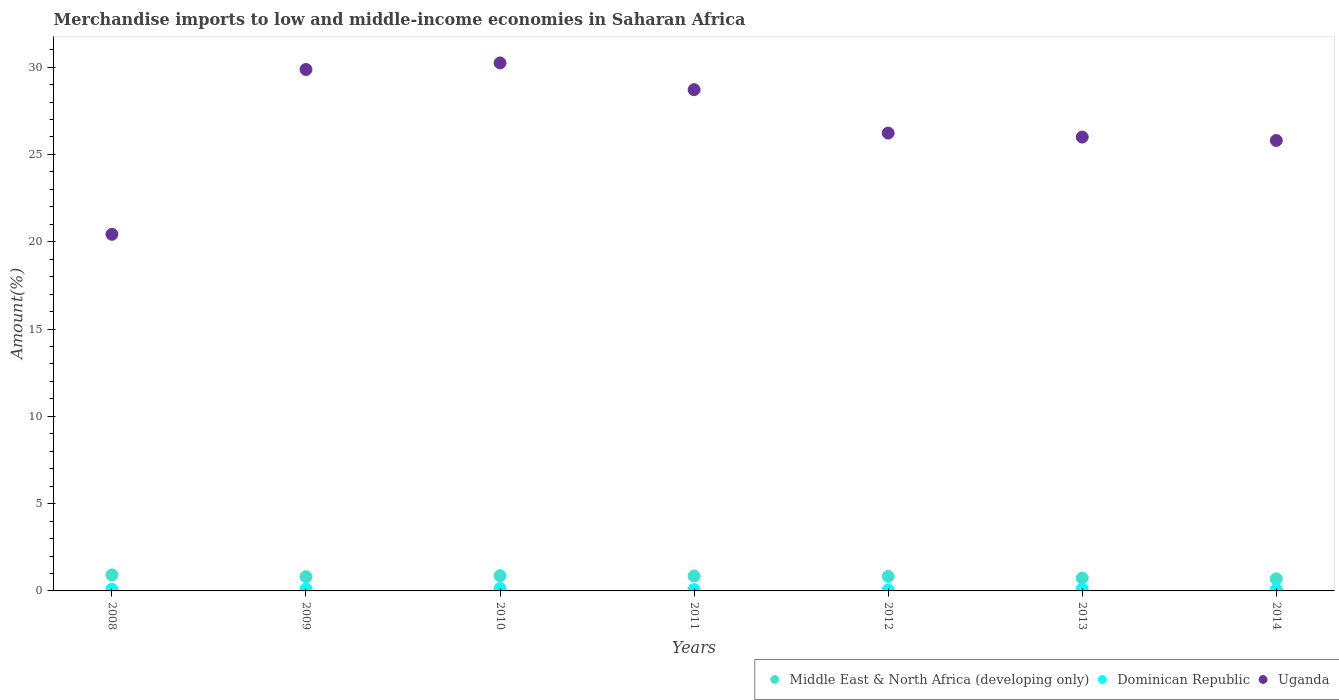How many different coloured dotlines are there?
Give a very brief answer. 3. Is the number of dotlines equal to the number of legend labels?
Provide a succinct answer. Yes. What is the percentage of amount earned from merchandise imports in Middle East & North Africa (developing only) in 2008?
Your answer should be very brief. 0.92. Across all years, what is the maximum percentage of amount earned from merchandise imports in Dominican Republic?
Offer a terse response. 0.14. Across all years, what is the minimum percentage of amount earned from merchandise imports in Middle East & North Africa (developing only)?
Provide a succinct answer. 0.69. In which year was the percentage of amount earned from merchandise imports in Uganda minimum?
Offer a terse response. 2008. What is the total percentage of amount earned from merchandise imports in Dominican Republic in the graph?
Your response must be concise. 0.66. What is the difference between the percentage of amount earned from merchandise imports in Dominican Republic in 2009 and that in 2012?
Your answer should be very brief. 0.05. What is the difference between the percentage of amount earned from merchandise imports in Middle East & North Africa (developing only) in 2009 and the percentage of amount earned from merchandise imports in Uganda in 2010?
Your answer should be compact. -29.43. What is the average percentage of amount earned from merchandise imports in Dominican Republic per year?
Provide a short and direct response. 0.09. In the year 2014, what is the difference between the percentage of amount earned from merchandise imports in Uganda and percentage of amount earned from merchandise imports in Middle East & North Africa (developing only)?
Provide a short and direct response. 25.11. In how many years, is the percentage of amount earned from merchandise imports in Uganda greater than 10 %?
Your response must be concise. 7. What is the ratio of the percentage of amount earned from merchandise imports in Uganda in 2009 to that in 2013?
Offer a very short reply. 1.15. Is the difference between the percentage of amount earned from merchandise imports in Uganda in 2011 and 2012 greater than the difference between the percentage of amount earned from merchandise imports in Middle East & North Africa (developing only) in 2011 and 2012?
Your answer should be compact. Yes. What is the difference between the highest and the second highest percentage of amount earned from merchandise imports in Dominican Republic?
Offer a very short reply. 0.02. What is the difference between the highest and the lowest percentage of amount earned from merchandise imports in Uganda?
Provide a succinct answer. 9.82. Is it the case that in every year, the sum of the percentage of amount earned from merchandise imports in Middle East & North Africa (developing only) and percentage of amount earned from merchandise imports in Dominican Republic  is greater than the percentage of amount earned from merchandise imports in Uganda?
Provide a short and direct response. No. Does the percentage of amount earned from merchandise imports in Uganda monotonically increase over the years?
Your response must be concise. No. Is the percentage of amount earned from merchandise imports in Middle East & North Africa (developing only) strictly less than the percentage of amount earned from merchandise imports in Uganda over the years?
Keep it short and to the point. Yes. How many dotlines are there?
Your answer should be compact. 3. How many years are there in the graph?
Your answer should be compact. 7. What is the difference between two consecutive major ticks on the Y-axis?
Keep it short and to the point. 5. Does the graph contain any zero values?
Your answer should be very brief. No. Does the graph contain grids?
Offer a very short reply. No. How many legend labels are there?
Your answer should be very brief. 3. What is the title of the graph?
Provide a short and direct response. Merchandise imports to low and middle-income economies in Saharan Africa. What is the label or title of the X-axis?
Provide a short and direct response. Years. What is the label or title of the Y-axis?
Give a very brief answer. Amount(%). What is the Amount(%) in Middle East & North Africa (developing only) in 2008?
Your response must be concise. 0.92. What is the Amount(%) of Dominican Republic in 2008?
Provide a succinct answer. 0.09. What is the Amount(%) in Uganda in 2008?
Ensure brevity in your answer.  20.43. What is the Amount(%) of Middle East & North Africa (developing only) in 2009?
Ensure brevity in your answer.  0.81. What is the Amount(%) in Dominican Republic in 2009?
Your answer should be very brief. 0.11. What is the Amount(%) of Uganda in 2009?
Provide a short and direct response. 29.87. What is the Amount(%) of Middle East & North Africa (developing only) in 2010?
Provide a succinct answer. 0.87. What is the Amount(%) in Dominican Republic in 2010?
Make the answer very short. 0.14. What is the Amount(%) in Uganda in 2010?
Give a very brief answer. 30.24. What is the Amount(%) in Middle East & North Africa (developing only) in 2011?
Your response must be concise. 0.85. What is the Amount(%) in Dominican Republic in 2011?
Your answer should be very brief. 0.08. What is the Amount(%) of Uganda in 2011?
Offer a very short reply. 28.71. What is the Amount(%) in Middle East & North Africa (developing only) in 2012?
Provide a short and direct response. 0.83. What is the Amount(%) in Dominican Republic in 2012?
Make the answer very short. 0.06. What is the Amount(%) of Uganda in 2012?
Give a very brief answer. 26.22. What is the Amount(%) in Middle East & North Africa (developing only) in 2013?
Your answer should be very brief. 0.74. What is the Amount(%) of Dominican Republic in 2013?
Offer a terse response. 0.1. What is the Amount(%) of Uganda in 2013?
Provide a succinct answer. 25.99. What is the Amount(%) in Middle East & North Africa (developing only) in 2014?
Provide a succinct answer. 0.69. What is the Amount(%) in Dominican Republic in 2014?
Keep it short and to the point. 0.09. What is the Amount(%) of Uganda in 2014?
Keep it short and to the point. 25.8. Across all years, what is the maximum Amount(%) in Middle East & North Africa (developing only)?
Your response must be concise. 0.92. Across all years, what is the maximum Amount(%) of Dominican Republic?
Keep it short and to the point. 0.14. Across all years, what is the maximum Amount(%) of Uganda?
Keep it short and to the point. 30.24. Across all years, what is the minimum Amount(%) of Middle East & North Africa (developing only)?
Provide a succinct answer. 0.69. Across all years, what is the minimum Amount(%) in Dominican Republic?
Offer a very short reply. 0.06. Across all years, what is the minimum Amount(%) in Uganda?
Provide a short and direct response. 20.43. What is the total Amount(%) of Middle East & North Africa (developing only) in the graph?
Give a very brief answer. 5.72. What is the total Amount(%) in Dominican Republic in the graph?
Ensure brevity in your answer.  0.66. What is the total Amount(%) of Uganda in the graph?
Offer a very short reply. 187.26. What is the difference between the Amount(%) in Middle East & North Africa (developing only) in 2008 and that in 2009?
Provide a succinct answer. 0.1. What is the difference between the Amount(%) of Dominican Republic in 2008 and that in 2009?
Give a very brief answer. -0.02. What is the difference between the Amount(%) of Uganda in 2008 and that in 2009?
Make the answer very short. -9.44. What is the difference between the Amount(%) in Middle East & North Africa (developing only) in 2008 and that in 2010?
Offer a very short reply. 0.05. What is the difference between the Amount(%) of Dominican Republic in 2008 and that in 2010?
Your response must be concise. -0.05. What is the difference between the Amount(%) of Uganda in 2008 and that in 2010?
Your answer should be compact. -9.82. What is the difference between the Amount(%) of Middle East & North Africa (developing only) in 2008 and that in 2011?
Provide a succinct answer. 0.06. What is the difference between the Amount(%) in Dominican Republic in 2008 and that in 2011?
Give a very brief answer. 0.01. What is the difference between the Amount(%) of Uganda in 2008 and that in 2011?
Your response must be concise. -8.29. What is the difference between the Amount(%) in Middle East & North Africa (developing only) in 2008 and that in 2012?
Offer a terse response. 0.09. What is the difference between the Amount(%) of Dominican Republic in 2008 and that in 2012?
Your answer should be very brief. 0.03. What is the difference between the Amount(%) in Uganda in 2008 and that in 2012?
Keep it short and to the point. -5.8. What is the difference between the Amount(%) in Middle East & North Africa (developing only) in 2008 and that in 2013?
Keep it short and to the point. 0.18. What is the difference between the Amount(%) in Dominican Republic in 2008 and that in 2013?
Provide a succinct answer. -0.02. What is the difference between the Amount(%) of Uganda in 2008 and that in 2013?
Make the answer very short. -5.57. What is the difference between the Amount(%) in Middle East & North Africa (developing only) in 2008 and that in 2014?
Your answer should be very brief. 0.22. What is the difference between the Amount(%) in Dominican Republic in 2008 and that in 2014?
Ensure brevity in your answer.  0. What is the difference between the Amount(%) of Uganda in 2008 and that in 2014?
Your answer should be very brief. -5.38. What is the difference between the Amount(%) of Middle East & North Africa (developing only) in 2009 and that in 2010?
Provide a succinct answer. -0.06. What is the difference between the Amount(%) of Dominican Republic in 2009 and that in 2010?
Make the answer very short. -0.02. What is the difference between the Amount(%) of Uganda in 2009 and that in 2010?
Provide a succinct answer. -0.38. What is the difference between the Amount(%) of Middle East & North Africa (developing only) in 2009 and that in 2011?
Ensure brevity in your answer.  -0.04. What is the difference between the Amount(%) of Dominican Republic in 2009 and that in 2011?
Give a very brief answer. 0.03. What is the difference between the Amount(%) in Uganda in 2009 and that in 2011?
Your answer should be very brief. 1.16. What is the difference between the Amount(%) of Middle East & North Africa (developing only) in 2009 and that in 2012?
Provide a short and direct response. -0.02. What is the difference between the Amount(%) of Dominican Republic in 2009 and that in 2012?
Your response must be concise. 0.05. What is the difference between the Amount(%) in Uganda in 2009 and that in 2012?
Provide a short and direct response. 3.64. What is the difference between the Amount(%) of Middle East & North Africa (developing only) in 2009 and that in 2013?
Provide a succinct answer. 0.08. What is the difference between the Amount(%) in Dominican Republic in 2009 and that in 2013?
Your answer should be compact. 0.01. What is the difference between the Amount(%) of Uganda in 2009 and that in 2013?
Your answer should be very brief. 3.87. What is the difference between the Amount(%) in Middle East & North Africa (developing only) in 2009 and that in 2014?
Your answer should be compact. 0.12. What is the difference between the Amount(%) in Dominican Republic in 2009 and that in 2014?
Keep it short and to the point. 0.03. What is the difference between the Amount(%) in Uganda in 2009 and that in 2014?
Your answer should be very brief. 4.07. What is the difference between the Amount(%) in Middle East & North Africa (developing only) in 2010 and that in 2011?
Give a very brief answer. 0.02. What is the difference between the Amount(%) of Dominican Republic in 2010 and that in 2011?
Offer a very short reply. 0.06. What is the difference between the Amount(%) in Uganda in 2010 and that in 2011?
Provide a short and direct response. 1.53. What is the difference between the Amount(%) of Middle East & North Africa (developing only) in 2010 and that in 2012?
Offer a very short reply. 0.04. What is the difference between the Amount(%) of Dominican Republic in 2010 and that in 2012?
Provide a succinct answer. 0.07. What is the difference between the Amount(%) of Uganda in 2010 and that in 2012?
Offer a very short reply. 4.02. What is the difference between the Amount(%) in Middle East & North Africa (developing only) in 2010 and that in 2013?
Your answer should be very brief. 0.13. What is the difference between the Amount(%) of Dominican Republic in 2010 and that in 2013?
Make the answer very short. 0.03. What is the difference between the Amount(%) in Uganda in 2010 and that in 2013?
Provide a short and direct response. 4.25. What is the difference between the Amount(%) in Middle East & North Africa (developing only) in 2010 and that in 2014?
Ensure brevity in your answer.  0.18. What is the difference between the Amount(%) in Dominican Republic in 2010 and that in 2014?
Provide a succinct answer. 0.05. What is the difference between the Amount(%) in Uganda in 2010 and that in 2014?
Provide a succinct answer. 4.44. What is the difference between the Amount(%) of Middle East & North Africa (developing only) in 2011 and that in 2012?
Provide a succinct answer. 0.02. What is the difference between the Amount(%) of Dominican Republic in 2011 and that in 2012?
Give a very brief answer. 0.02. What is the difference between the Amount(%) in Uganda in 2011 and that in 2012?
Make the answer very short. 2.49. What is the difference between the Amount(%) in Middle East & North Africa (developing only) in 2011 and that in 2013?
Ensure brevity in your answer.  0.12. What is the difference between the Amount(%) in Dominican Republic in 2011 and that in 2013?
Your answer should be compact. -0.03. What is the difference between the Amount(%) of Uganda in 2011 and that in 2013?
Your answer should be very brief. 2.72. What is the difference between the Amount(%) in Middle East & North Africa (developing only) in 2011 and that in 2014?
Provide a succinct answer. 0.16. What is the difference between the Amount(%) of Dominican Republic in 2011 and that in 2014?
Your answer should be compact. -0.01. What is the difference between the Amount(%) in Uganda in 2011 and that in 2014?
Make the answer very short. 2.91. What is the difference between the Amount(%) in Middle East & North Africa (developing only) in 2012 and that in 2013?
Give a very brief answer. 0.09. What is the difference between the Amount(%) of Dominican Republic in 2012 and that in 2013?
Make the answer very short. -0.04. What is the difference between the Amount(%) of Uganda in 2012 and that in 2013?
Give a very brief answer. 0.23. What is the difference between the Amount(%) in Middle East & North Africa (developing only) in 2012 and that in 2014?
Your answer should be very brief. 0.14. What is the difference between the Amount(%) of Dominican Republic in 2012 and that in 2014?
Give a very brief answer. -0.02. What is the difference between the Amount(%) of Uganda in 2012 and that in 2014?
Offer a terse response. 0.42. What is the difference between the Amount(%) in Middle East & North Africa (developing only) in 2013 and that in 2014?
Your answer should be compact. 0.05. What is the difference between the Amount(%) of Dominican Republic in 2013 and that in 2014?
Offer a very short reply. 0.02. What is the difference between the Amount(%) in Uganda in 2013 and that in 2014?
Offer a terse response. 0.19. What is the difference between the Amount(%) of Middle East & North Africa (developing only) in 2008 and the Amount(%) of Dominican Republic in 2009?
Keep it short and to the point. 0.81. What is the difference between the Amount(%) of Middle East & North Africa (developing only) in 2008 and the Amount(%) of Uganda in 2009?
Provide a short and direct response. -28.95. What is the difference between the Amount(%) of Dominican Republic in 2008 and the Amount(%) of Uganda in 2009?
Your response must be concise. -29.78. What is the difference between the Amount(%) in Middle East & North Africa (developing only) in 2008 and the Amount(%) in Dominican Republic in 2010?
Keep it short and to the point. 0.78. What is the difference between the Amount(%) in Middle East & North Africa (developing only) in 2008 and the Amount(%) in Uganda in 2010?
Provide a succinct answer. -29.33. What is the difference between the Amount(%) of Dominican Republic in 2008 and the Amount(%) of Uganda in 2010?
Keep it short and to the point. -30.15. What is the difference between the Amount(%) in Middle East & North Africa (developing only) in 2008 and the Amount(%) in Dominican Republic in 2011?
Provide a short and direct response. 0.84. What is the difference between the Amount(%) in Middle East & North Africa (developing only) in 2008 and the Amount(%) in Uganda in 2011?
Offer a very short reply. -27.79. What is the difference between the Amount(%) in Dominican Republic in 2008 and the Amount(%) in Uganda in 2011?
Make the answer very short. -28.62. What is the difference between the Amount(%) in Middle East & North Africa (developing only) in 2008 and the Amount(%) in Dominican Republic in 2012?
Provide a succinct answer. 0.86. What is the difference between the Amount(%) of Middle East & North Africa (developing only) in 2008 and the Amount(%) of Uganda in 2012?
Keep it short and to the point. -25.31. What is the difference between the Amount(%) of Dominican Republic in 2008 and the Amount(%) of Uganda in 2012?
Offer a terse response. -26.13. What is the difference between the Amount(%) of Middle East & North Africa (developing only) in 2008 and the Amount(%) of Dominican Republic in 2013?
Provide a succinct answer. 0.81. What is the difference between the Amount(%) of Middle East & North Africa (developing only) in 2008 and the Amount(%) of Uganda in 2013?
Keep it short and to the point. -25.08. What is the difference between the Amount(%) of Dominican Republic in 2008 and the Amount(%) of Uganda in 2013?
Ensure brevity in your answer.  -25.91. What is the difference between the Amount(%) of Middle East & North Africa (developing only) in 2008 and the Amount(%) of Dominican Republic in 2014?
Offer a terse response. 0.83. What is the difference between the Amount(%) of Middle East & North Africa (developing only) in 2008 and the Amount(%) of Uganda in 2014?
Keep it short and to the point. -24.88. What is the difference between the Amount(%) of Dominican Republic in 2008 and the Amount(%) of Uganda in 2014?
Provide a short and direct response. -25.71. What is the difference between the Amount(%) in Middle East & North Africa (developing only) in 2009 and the Amount(%) in Dominican Republic in 2010?
Your answer should be compact. 0.68. What is the difference between the Amount(%) in Middle East & North Africa (developing only) in 2009 and the Amount(%) in Uganda in 2010?
Keep it short and to the point. -29.43. What is the difference between the Amount(%) in Dominican Republic in 2009 and the Amount(%) in Uganda in 2010?
Ensure brevity in your answer.  -30.13. What is the difference between the Amount(%) in Middle East & North Africa (developing only) in 2009 and the Amount(%) in Dominican Republic in 2011?
Your answer should be very brief. 0.74. What is the difference between the Amount(%) of Middle East & North Africa (developing only) in 2009 and the Amount(%) of Uganda in 2011?
Provide a succinct answer. -27.9. What is the difference between the Amount(%) in Dominican Republic in 2009 and the Amount(%) in Uganda in 2011?
Offer a very short reply. -28.6. What is the difference between the Amount(%) in Middle East & North Africa (developing only) in 2009 and the Amount(%) in Dominican Republic in 2012?
Keep it short and to the point. 0.75. What is the difference between the Amount(%) in Middle East & North Africa (developing only) in 2009 and the Amount(%) in Uganda in 2012?
Provide a succinct answer. -25.41. What is the difference between the Amount(%) of Dominican Republic in 2009 and the Amount(%) of Uganda in 2012?
Your answer should be compact. -26.11. What is the difference between the Amount(%) in Middle East & North Africa (developing only) in 2009 and the Amount(%) in Dominican Republic in 2013?
Make the answer very short. 0.71. What is the difference between the Amount(%) in Middle East & North Africa (developing only) in 2009 and the Amount(%) in Uganda in 2013?
Give a very brief answer. -25.18. What is the difference between the Amount(%) of Dominican Republic in 2009 and the Amount(%) of Uganda in 2013?
Offer a very short reply. -25.88. What is the difference between the Amount(%) of Middle East & North Africa (developing only) in 2009 and the Amount(%) of Dominican Republic in 2014?
Ensure brevity in your answer.  0.73. What is the difference between the Amount(%) in Middle East & North Africa (developing only) in 2009 and the Amount(%) in Uganda in 2014?
Give a very brief answer. -24.99. What is the difference between the Amount(%) of Dominican Republic in 2009 and the Amount(%) of Uganda in 2014?
Give a very brief answer. -25.69. What is the difference between the Amount(%) in Middle East & North Africa (developing only) in 2010 and the Amount(%) in Dominican Republic in 2011?
Offer a very short reply. 0.79. What is the difference between the Amount(%) of Middle East & North Africa (developing only) in 2010 and the Amount(%) of Uganda in 2011?
Your answer should be compact. -27.84. What is the difference between the Amount(%) in Dominican Republic in 2010 and the Amount(%) in Uganda in 2011?
Offer a very short reply. -28.57. What is the difference between the Amount(%) in Middle East & North Africa (developing only) in 2010 and the Amount(%) in Dominican Republic in 2012?
Make the answer very short. 0.81. What is the difference between the Amount(%) of Middle East & North Africa (developing only) in 2010 and the Amount(%) of Uganda in 2012?
Make the answer very short. -25.35. What is the difference between the Amount(%) in Dominican Republic in 2010 and the Amount(%) in Uganda in 2012?
Your answer should be compact. -26.09. What is the difference between the Amount(%) of Middle East & North Africa (developing only) in 2010 and the Amount(%) of Dominican Republic in 2013?
Keep it short and to the point. 0.77. What is the difference between the Amount(%) in Middle East & North Africa (developing only) in 2010 and the Amount(%) in Uganda in 2013?
Your answer should be very brief. -25.12. What is the difference between the Amount(%) of Dominican Republic in 2010 and the Amount(%) of Uganda in 2013?
Offer a very short reply. -25.86. What is the difference between the Amount(%) of Middle East & North Africa (developing only) in 2010 and the Amount(%) of Dominican Republic in 2014?
Ensure brevity in your answer.  0.79. What is the difference between the Amount(%) in Middle East & North Africa (developing only) in 2010 and the Amount(%) in Uganda in 2014?
Ensure brevity in your answer.  -24.93. What is the difference between the Amount(%) in Dominican Republic in 2010 and the Amount(%) in Uganda in 2014?
Offer a very short reply. -25.66. What is the difference between the Amount(%) of Middle East & North Africa (developing only) in 2011 and the Amount(%) of Dominican Republic in 2012?
Offer a terse response. 0.79. What is the difference between the Amount(%) in Middle East & North Africa (developing only) in 2011 and the Amount(%) in Uganda in 2012?
Provide a succinct answer. -25.37. What is the difference between the Amount(%) of Dominican Republic in 2011 and the Amount(%) of Uganda in 2012?
Make the answer very short. -26.15. What is the difference between the Amount(%) in Middle East & North Africa (developing only) in 2011 and the Amount(%) in Dominican Republic in 2013?
Your response must be concise. 0.75. What is the difference between the Amount(%) of Middle East & North Africa (developing only) in 2011 and the Amount(%) of Uganda in 2013?
Keep it short and to the point. -25.14. What is the difference between the Amount(%) of Dominican Republic in 2011 and the Amount(%) of Uganda in 2013?
Your answer should be compact. -25.92. What is the difference between the Amount(%) of Middle East & North Africa (developing only) in 2011 and the Amount(%) of Dominican Republic in 2014?
Ensure brevity in your answer.  0.77. What is the difference between the Amount(%) in Middle East & North Africa (developing only) in 2011 and the Amount(%) in Uganda in 2014?
Your answer should be very brief. -24.95. What is the difference between the Amount(%) in Dominican Republic in 2011 and the Amount(%) in Uganda in 2014?
Keep it short and to the point. -25.72. What is the difference between the Amount(%) of Middle East & North Africa (developing only) in 2012 and the Amount(%) of Dominican Republic in 2013?
Your answer should be compact. 0.73. What is the difference between the Amount(%) in Middle East & North Africa (developing only) in 2012 and the Amount(%) in Uganda in 2013?
Give a very brief answer. -25.16. What is the difference between the Amount(%) of Dominican Republic in 2012 and the Amount(%) of Uganda in 2013?
Make the answer very short. -25.93. What is the difference between the Amount(%) of Middle East & North Africa (developing only) in 2012 and the Amount(%) of Dominican Republic in 2014?
Provide a short and direct response. 0.75. What is the difference between the Amount(%) in Middle East & North Africa (developing only) in 2012 and the Amount(%) in Uganda in 2014?
Ensure brevity in your answer.  -24.97. What is the difference between the Amount(%) in Dominican Republic in 2012 and the Amount(%) in Uganda in 2014?
Offer a terse response. -25.74. What is the difference between the Amount(%) in Middle East & North Africa (developing only) in 2013 and the Amount(%) in Dominican Republic in 2014?
Ensure brevity in your answer.  0.65. What is the difference between the Amount(%) in Middle East & North Africa (developing only) in 2013 and the Amount(%) in Uganda in 2014?
Give a very brief answer. -25.06. What is the difference between the Amount(%) in Dominican Republic in 2013 and the Amount(%) in Uganda in 2014?
Provide a succinct answer. -25.7. What is the average Amount(%) in Middle East & North Africa (developing only) per year?
Offer a terse response. 0.82. What is the average Amount(%) of Dominican Republic per year?
Provide a succinct answer. 0.1. What is the average Amount(%) in Uganda per year?
Offer a very short reply. 26.75. In the year 2008, what is the difference between the Amount(%) of Middle East & North Africa (developing only) and Amount(%) of Dominican Republic?
Offer a very short reply. 0.83. In the year 2008, what is the difference between the Amount(%) in Middle East & North Africa (developing only) and Amount(%) in Uganda?
Your response must be concise. -19.51. In the year 2008, what is the difference between the Amount(%) in Dominican Republic and Amount(%) in Uganda?
Offer a terse response. -20.34. In the year 2009, what is the difference between the Amount(%) in Middle East & North Africa (developing only) and Amount(%) in Dominican Republic?
Your answer should be very brief. 0.7. In the year 2009, what is the difference between the Amount(%) in Middle East & North Africa (developing only) and Amount(%) in Uganda?
Give a very brief answer. -29.05. In the year 2009, what is the difference between the Amount(%) in Dominican Republic and Amount(%) in Uganda?
Your answer should be compact. -29.76. In the year 2010, what is the difference between the Amount(%) in Middle East & North Africa (developing only) and Amount(%) in Dominican Republic?
Your answer should be compact. 0.73. In the year 2010, what is the difference between the Amount(%) of Middle East & North Africa (developing only) and Amount(%) of Uganda?
Give a very brief answer. -29.37. In the year 2010, what is the difference between the Amount(%) of Dominican Republic and Amount(%) of Uganda?
Your response must be concise. -30.11. In the year 2011, what is the difference between the Amount(%) in Middle East & North Africa (developing only) and Amount(%) in Dominican Republic?
Offer a very short reply. 0.78. In the year 2011, what is the difference between the Amount(%) in Middle East & North Africa (developing only) and Amount(%) in Uganda?
Provide a short and direct response. -27.86. In the year 2011, what is the difference between the Amount(%) of Dominican Republic and Amount(%) of Uganda?
Make the answer very short. -28.63. In the year 2012, what is the difference between the Amount(%) in Middle East & North Africa (developing only) and Amount(%) in Dominican Republic?
Keep it short and to the point. 0.77. In the year 2012, what is the difference between the Amount(%) of Middle East & North Africa (developing only) and Amount(%) of Uganda?
Offer a very short reply. -25.39. In the year 2012, what is the difference between the Amount(%) in Dominican Republic and Amount(%) in Uganda?
Make the answer very short. -26.16. In the year 2013, what is the difference between the Amount(%) in Middle East & North Africa (developing only) and Amount(%) in Dominican Republic?
Your answer should be compact. 0.63. In the year 2013, what is the difference between the Amount(%) of Middle East & North Africa (developing only) and Amount(%) of Uganda?
Your answer should be compact. -25.26. In the year 2013, what is the difference between the Amount(%) of Dominican Republic and Amount(%) of Uganda?
Your answer should be very brief. -25.89. In the year 2014, what is the difference between the Amount(%) of Middle East & North Africa (developing only) and Amount(%) of Dominican Republic?
Your answer should be very brief. 0.61. In the year 2014, what is the difference between the Amount(%) in Middle East & North Africa (developing only) and Amount(%) in Uganda?
Your answer should be compact. -25.11. In the year 2014, what is the difference between the Amount(%) in Dominican Republic and Amount(%) in Uganda?
Ensure brevity in your answer.  -25.72. What is the ratio of the Amount(%) of Middle East & North Africa (developing only) in 2008 to that in 2009?
Offer a terse response. 1.13. What is the ratio of the Amount(%) of Dominican Republic in 2008 to that in 2009?
Provide a short and direct response. 0.8. What is the ratio of the Amount(%) of Uganda in 2008 to that in 2009?
Make the answer very short. 0.68. What is the ratio of the Amount(%) in Middle East & North Africa (developing only) in 2008 to that in 2010?
Offer a very short reply. 1.05. What is the ratio of the Amount(%) of Dominican Republic in 2008 to that in 2010?
Ensure brevity in your answer.  0.65. What is the ratio of the Amount(%) in Uganda in 2008 to that in 2010?
Provide a short and direct response. 0.68. What is the ratio of the Amount(%) of Middle East & North Africa (developing only) in 2008 to that in 2011?
Provide a short and direct response. 1.07. What is the ratio of the Amount(%) of Dominican Republic in 2008 to that in 2011?
Your answer should be compact. 1.14. What is the ratio of the Amount(%) in Uganda in 2008 to that in 2011?
Make the answer very short. 0.71. What is the ratio of the Amount(%) of Middle East & North Africa (developing only) in 2008 to that in 2012?
Ensure brevity in your answer.  1.1. What is the ratio of the Amount(%) in Dominican Republic in 2008 to that in 2012?
Give a very brief answer. 1.46. What is the ratio of the Amount(%) of Uganda in 2008 to that in 2012?
Give a very brief answer. 0.78. What is the ratio of the Amount(%) in Middle East & North Africa (developing only) in 2008 to that in 2013?
Give a very brief answer. 1.24. What is the ratio of the Amount(%) of Dominican Republic in 2008 to that in 2013?
Make the answer very short. 0.85. What is the ratio of the Amount(%) in Uganda in 2008 to that in 2013?
Offer a very short reply. 0.79. What is the ratio of the Amount(%) of Middle East & North Africa (developing only) in 2008 to that in 2014?
Offer a terse response. 1.32. What is the ratio of the Amount(%) of Dominican Republic in 2008 to that in 2014?
Ensure brevity in your answer.  1.04. What is the ratio of the Amount(%) in Uganda in 2008 to that in 2014?
Keep it short and to the point. 0.79. What is the ratio of the Amount(%) of Middle East & North Africa (developing only) in 2009 to that in 2010?
Provide a short and direct response. 0.93. What is the ratio of the Amount(%) of Dominican Republic in 2009 to that in 2010?
Offer a very short reply. 0.82. What is the ratio of the Amount(%) of Uganda in 2009 to that in 2010?
Offer a very short reply. 0.99. What is the ratio of the Amount(%) of Middle East & North Africa (developing only) in 2009 to that in 2011?
Ensure brevity in your answer.  0.95. What is the ratio of the Amount(%) of Dominican Republic in 2009 to that in 2011?
Provide a succinct answer. 1.43. What is the ratio of the Amount(%) of Uganda in 2009 to that in 2011?
Give a very brief answer. 1.04. What is the ratio of the Amount(%) of Middle East & North Africa (developing only) in 2009 to that in 2012?
Your answer should be very brief. 0.98. What is the ratio of the Amount(%) in Dominican Republic in 2009 to that in 2012?
Your answer should be compact. 1.83. What is the ratio of the Amount(%) of Uganda in 2009 to that in 2012?
Keep it short and to the point. 1.14. What is the ratio of the Amount(%) of Middle East & North Africa (developing only) in 2009 to that in 2013?
Keep it short and to the point. 1.1. What is the ratio of the Amount(%) of Dominican Republic in 2009 to that in 2013?
Your answer should be very brief. 1.06. What is the ratio of the Amount(%) of Uganda in 2009 to that in 2013?
Offer a very short reply. 1.15. What is the ratio of the Amount(%) of Middle East & North Africa (developing only) in 2009 to that in 2014?
Your answer should be compact. 1.17. What is the ratio of the Amount(%) of Dominican Republic in 2009 to that in 2014?
Your answer should be compact. 1.3. What is the ratio of the Amount(%) of Uganda in 2009 to that in 2014?
Your answer should be very brief. 1.16. What is the ratio of the Amount(%) of Middle East & North Africa (developing only) in 2010 to that in 2011?
Provide a succinct answer. 1.02. What is the ratio of the Amount(%) of Dominican Republic in 2010 to that in 2011?
Keep it short and to the point. 1.75. What is the ratio of the Amount(%) of Uganda in 2010 to that in 2011?
Make the answer very short. 1.05. What is the ratio of the Amount(%) of Middle East & North Africa (developing only) in 2010 to that in 2012?
Your answer should be compact. 1.05. What is the ratio of the Amount(%) of Dominican Republic in 2010 to that in 2012?
Give a very brief answer. 2.23. What is the ratio of the Amount(%) of Uganda in 2010 to that in 2012?
Keep it short and to the point. 1.15. What is the ratio of the Amount(%) of Middle East & North Africa (developing only) in 2010 to that in 2013?
Give a very brief answer. 1.18. What is the ratio of the Amount(%) of Dominican Republic in 2010 to that in 2013?
Offer a terse response. 1.29. What is the ratio of the Amount(%) of Uganda in 2010 to that in 2013?
Make the answer very short. 1.16. What is the ratio of the Amount(%) of Middle East & North Africa (developing only) in 2010 to that in 2014?
Provide a short and direct response. 1.26. What is the ratio of the Amount(%) of Dominican Republic in 2010 to that in 2014?
Offer a very short reply. 1.59. What is the ratio of the Amount(%) of Uganda in 2010 to that in 2014?
Offer a very short reply. 1.17. What is the ratio of the Amount(%) in Middle East & North Africa (developing only) in 2011 to that in 2012?
Keep it short and to the point. 1.03. What is the ratio of the Amount(%) in Dominican Republic in 2011 to that in 2012?
Provide a succinct answer. 1.28. What is the ratio of the Amount(%) in Uganda in 2011 to that in 2012?
Keep it short and to the point. 1.09. What is the ratio of the Amount(%) of Middle East & North Africa (developing only) in 2011 to that in 2013?
Give a very brief answer. 1.16. What is the ratio of the Amount(%) of Dominican Republic in 2011 to that in 2013?
Offer a very short reply. 0.74. What is the ratio of the Amount(%) in Uganda in 2011 to that in 2013?
Offer a terse response. 1.1. What is the ratio of the Amount(%) in Middle East & North Africa (developing only) in 2011 to that in 2014?
Keep it short and to the point. 1.23. What is the ratio of the Amount(%) in Dominican Republic in 2011 to that in 2014?
Provide a short and direct response. 0.91. What is the ratio of the Amount(%) of Uganda in 2011 to that in 2014?
Provide a short and direct response. 1.11. What is the ratio of the Amount(%) of Middle East & North Africa (developing only) in 2012 to that in 2013?
Provide a short and direct response. 1.13. What is the ratio of the Amount(%) in Dominican Republic in 2012 to that in 2013?
Keep it short and to the point. 0.58. What is the ratio of the Amount(%) in Uganda in 2012 to that in 2013?
Offer a terse response. 1.01. What is the ratio of the Amount(%) in Middle East & North Africa (developing only) in 2012 to that in 2014?
Ensure brevity in your answer.  1.2. What is the ratio of the Amount(%) in Dominican Republic in 2012 to that in 2014?
Give a very brief answer. 0.71. What is the ratio of the Amount(%) in Uganda in 2012 to that in 2014?
Your response must be concise. 1.02. What is the ratio of the Amount(%) of Middle East & North Africa (developing only) in 2013 to that in 2014?
Make the answer very short. 1.06. What is the ratio of the Amount(%) of Dominican Republic in 2013 to that in 2014?
Offer a terse response. 1.23. What is the ratio of the Amount(%) in Uganda in 2013 to that in 2014?
Make the answer very short. 1.01. What is the difference between the highest and the second highest Amount(%) in Middle East & North Africa (developing only)?
Your answer should be very brief. 0.05. What is the difference between the highest and the second highest Amount(%) in Dominican Republic?
Make the answer very short. 0.02. What is the difference between the highest and the second highest Amount(%) in Uganda?
Offer a very short reply. 0.38. What is the difference between the highest and the lowest Amount(%) in Middle East & North Africa (developing only)?
Ensure brevity in your answer.  0.22. What is the difference between the highest and the lowest Amount(%) in Dominican Republic?
Keep it short and to the point. 0.07. What is the difference between the highest and the lowest Amount(%) in Uganda?
Make the answer very short. 9.82. 